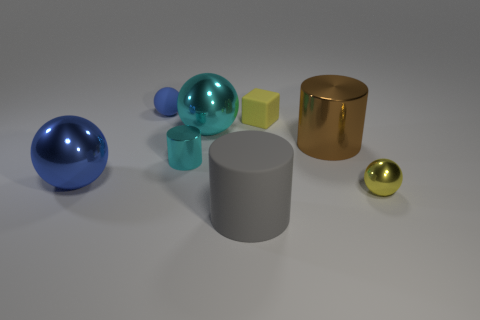Subtract all gray rubber cylinders. How many cylinders are left? 2 Add 1 red cylinders. How many objects exist? 9 Subtract all yellow spheres. How many spheres are left? 3 Subtract all blocks. How many objects are left? 7 Subtract 2 balls. How many balls are left? 2 Add 8 tiny purple cylinders. How many tiny purple cylinders exist? 8 Subtract 0 red cubes. How many objects are left? 8 Subtract all purple cubes. Subtract all green balls. How many cubes are left? 1 Subtract all yellow spheres. How many brown cylinders are left? 1 Subtract all metallic blocks. Subtract all tiny cyan cylinders. How many objects are left? 7 